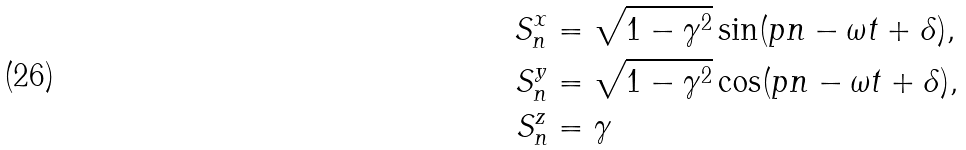Convert formula to latex. <formula><loc_0><loc_0><loc_500><loc_500>S ^ { x } _ { n } & = \sqrt { 1 - \gamma ^ { 2 } } \sin ( p n - \omega t + \delta ) , \\ S ^ { y } _ { n } & = \sqrt { 1 - \gamma ^ { 2 } } \cos ( p n - \omega t + \delta ) , \\ S ^ { z } _ { n } & = \gamma</formula> 